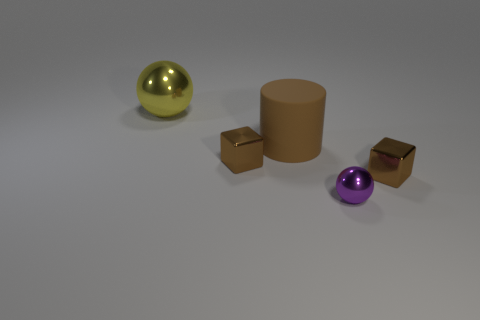How many other things are the same color as the large cylinder?
Ensure brevity in your answer.  2. What number of things are big brown cylinders or small objects?
Provide a succinct answer. 4. How many objects are either big yellow spheres or things that are in front of the large metallic thing?
Your answer should be compact. 5. Does the small ball have the same material as the big yellow object?
Make the answer very short. Yes. How many other objects are the same material as the small sphere?
Your response must be concise. 3. Are there more tiny brown metallic things than things?
Offer a terse response. No. Do the metal thing right of the purple shiny sphere and the large brown rubber thing have the same shape?
Offer a terse response. No. Are there fewer things than brown shiny cubes?
Offer a very short reply. No. What is the material of the yellow object that is the same size as the brown cylinder?
Provide a short and direct response. Metal. There is a cylinder; is it the same color as the tiny cube to the right of the small sphere?
Offer a very short reply. Yes. 